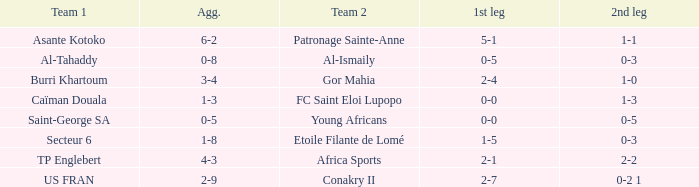For which teams was the sum of their scores 3-4? Burri Khartoum. 